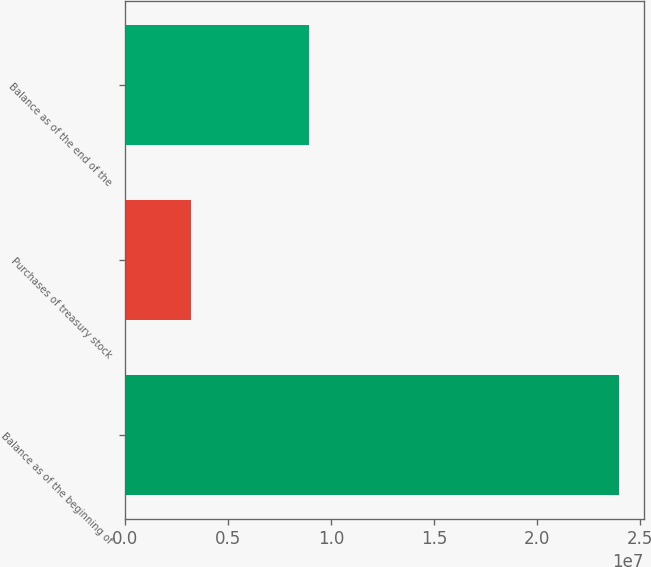Convert chart. <chart><loc_0><loc_0><loc_500><loc_500><bar_chart><fcel>Balance as of the beginning of<fcel>Purchases of treasury stock<fcel>Balance as of the end of the<nl><fcel>2.39868e+07<fcel>3.1922e+06<fcel>8.92814e+06<nl></chart> 